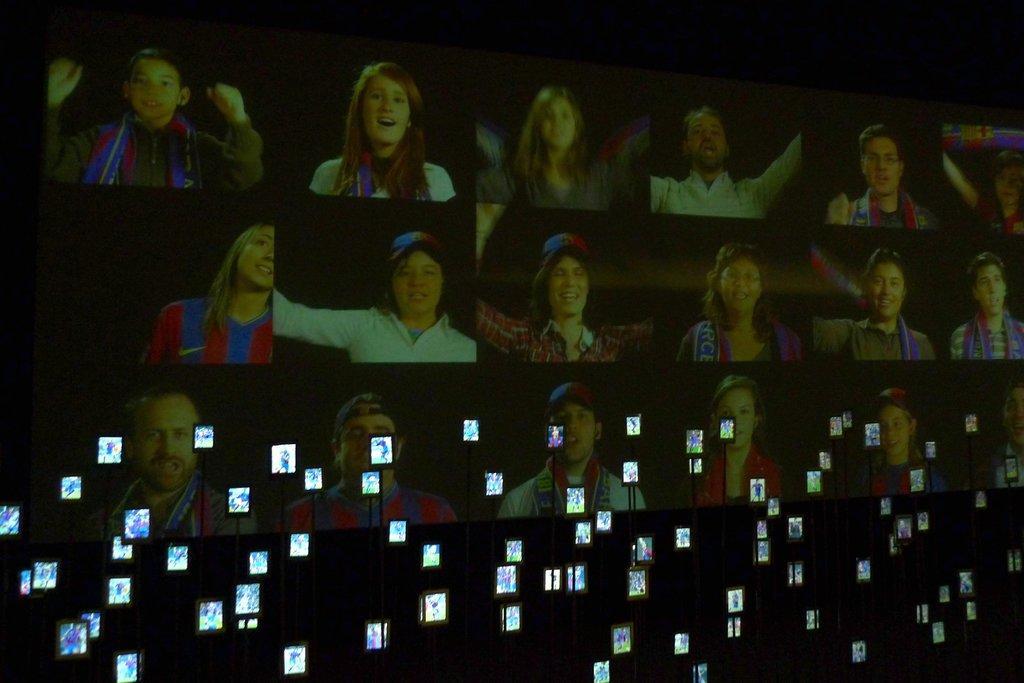How would you summarize this image in a sentence or two? In this image we can see a screen. At the bottom there are mobiles. 